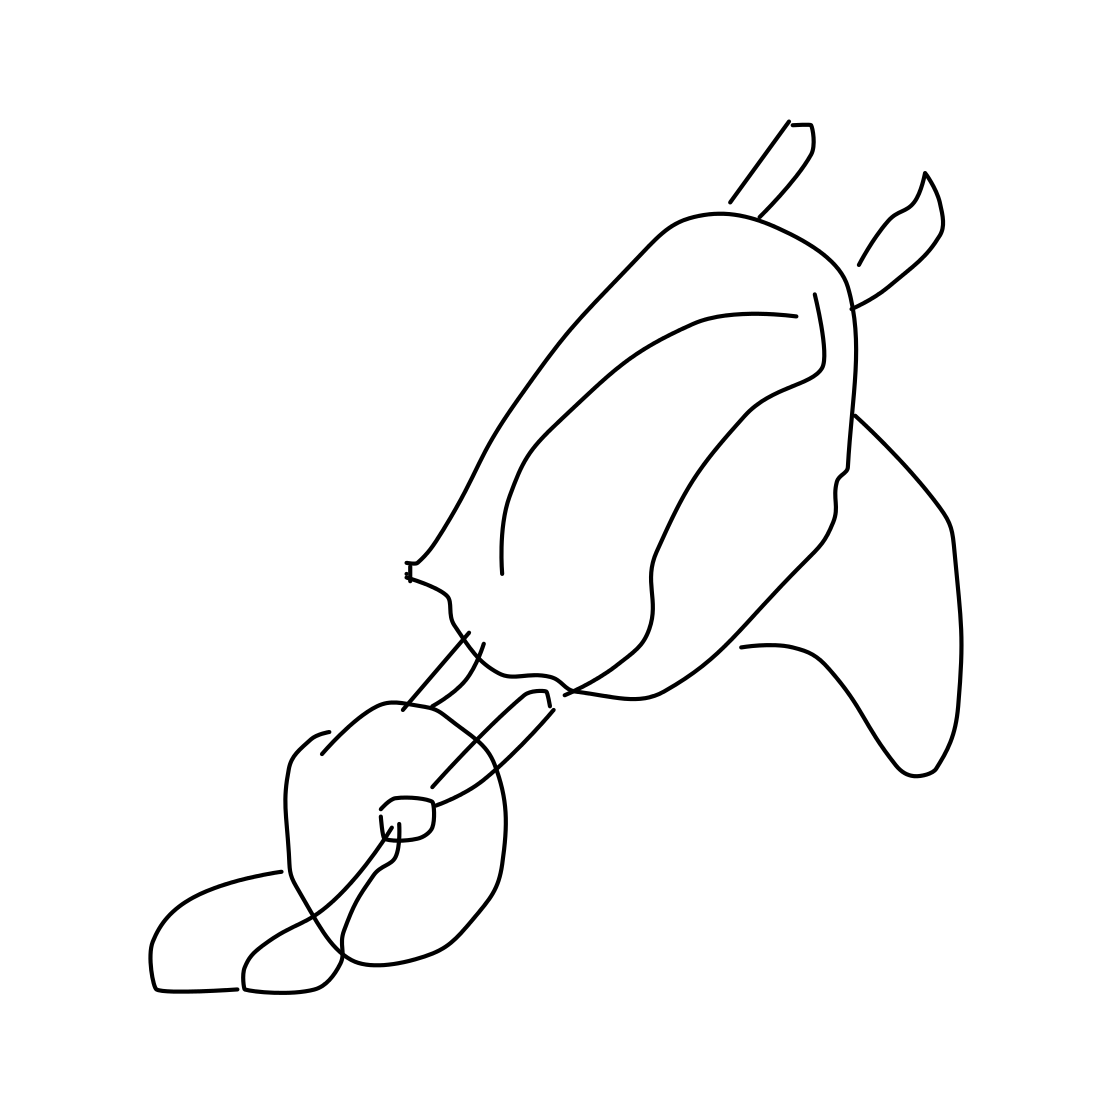Is there a sketchy wheelbarrow in the picture? Indeed, the image displays a sketch of a wheelbarrow, though it is a minimalist and abstract representation. The structure includes a wheel, two handles, and the body of the wheelbarrow, with the lines drawn in a freeform style that captures the essence of the object. 